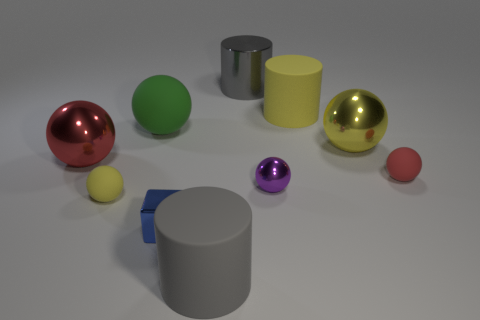Can you describe the lighting of the scene? The lighting in the scene appears to be soft and diffused, coming from above, as indicated by the gentle shadows under the objects. This suggests an evenly illuminated indoor setting, possibly in a studio. 